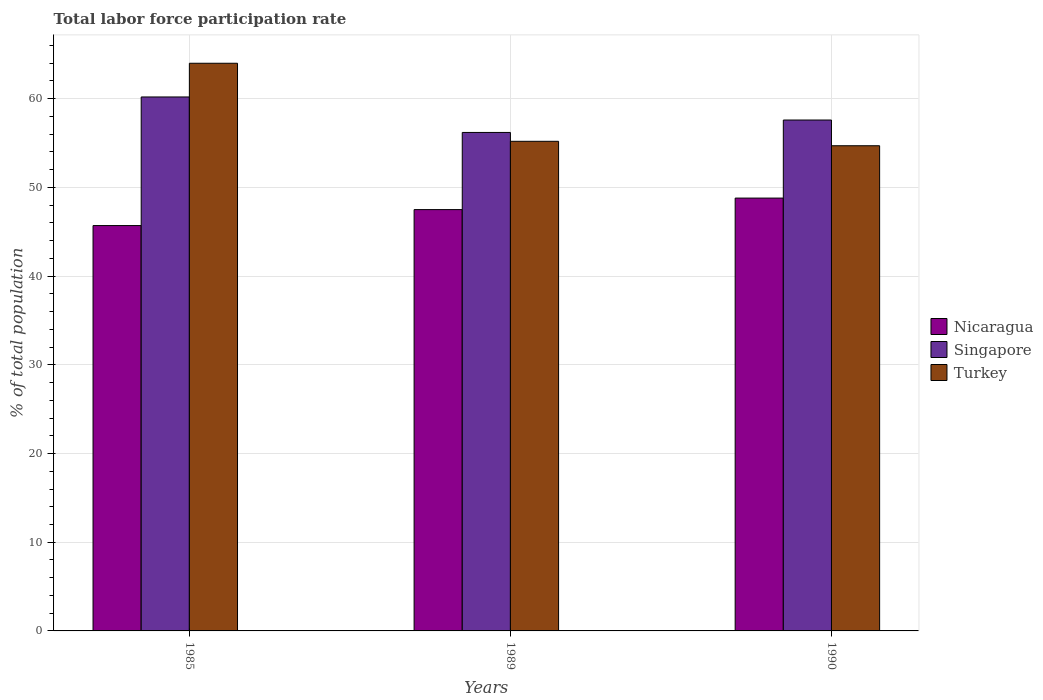How many groups of bars are there?
Your response must be concise. 3. How many bars are there on the 1st tick from the left?
Make the answer very short. 3. In how many cases, is the number of bars for a given year not equal to the number of legend labels?
Provide a succinct answer. 0. What is the total labor force participation rate in Nicaragua in 1990?
Make the answer very short. 48.8. Across all years, what is the maximum total labor force participation rate in Turkey?
Ensure brevity in your answer.  64. Across all years, what is the minimum total labor force participation rate in Turkey?
Provide a succinct answer. 54.7. What is the total total labor force participation rate in Singapore in the graph?
Ensure brevity in your answer.  174. What is the difference between the total labor force participation rate in Nicaragua in 1989 and that in 1990?
Provide a succinct answer. -1.3. What is the difference between the total labor force participation rate in Singapore in 1989 and the total labor force participation rate in Turkey in 1985?
Ensure brevity in your answer.  -7.8. What is the average total labor force participation rate in Turkey per year?
Keep it short and to the point. 57.97. In the year 1990, what is the difference between the total labor force participation rate in Nicaragua and total labor force participation rate in Turkey?
Keep it short and to the point. -5.9. In how many years, is the total labor force participation rate in Turkey greater than 46 %?
Make the answer very short. 3. What is the ratio of the total labor force participation rate in Singapore in 1985 to that in 1989?
Give a very brief answer. 1.07. Is the total labor force participation rate in Nicaragua in 1985 less than that in 1990?
Offer a very short reply. Yes. Is the difference between the total labor force participation rate in Nicaragua in 1985 and 1990 greater than the difference between the total labor force participation rate in Turkey in 1985 and 1990?
Make the answer very short. No. What is the difference between the highest and the second highest total labor force participation rate in Singapore?
Your answer should be very brief. 2.6. What is the difference between the highest and the lowest total labor force participation rate in Singapore?
Give a very brief answer. 4. Is the sum of the total labor force participation rate in Turkey in 1989 and 1990 greater than the maximum total labor force participation rate in Singapore across all years?
Provide a short and direct response. Yes. What does the 1st bar from the left in 1989 represents?
Keep it short and to the point. Nicaragua. What does the 2nd bar from the right in 1990 represents?
Give a very brief answer. Singapore. How many years are there in the graph?
Make the answer very short. 3. What is the difference between two consecutive major ticks on the Y-axis?
Give a very brief answer. 10. Are the values on the major ticks of Y-axis written in scientific E-notation?
Your answer should be compact. No. Does the graph contain any zero values?
Provide a short and direct response. No. Does the graph contain grids?
Your answer should be compact. Yes. How are the legend labels stacked?
Keep it short and to the point. Vertical. What is the title of the graph?
Provide a succinct answer. Total labor force participation rate. What is the label or title of the X-axis?
Provide a succinct answer. Years. What is the label or title of the Y-axis?
Offer a very short reply. % of total population. What is the % of total population in Nicaragua in 1985?
Offer a very short reply. 45.7. What is the % of total population of Singapore in 1985?
Keep it short and to the point. 60.2. What is the % of total population of Turkey in 1985?
Your answer should be compact. 64. What is the % of total population in Nicaragua in 1989?
Give a very brief answer. 47.5. What is the % of total population of Singapore in 1989?
Make the answer very short. 56.2. What is the % of total population of Turkey in 1989?
Keep it short and to the point. 55.2. What is the % of total population of Nicaragua in 1990?
Give a very brief answer. 48.8. What is the % of total population of Singapore in 1990?
Make the answer very short. 57.6. What is the % of total population of Turkey in 1990?
Make the answer very short. 54.7. Across all years, what is the maximum % of total population of Nicaragua?
Provide a short and direct response. 48.8. Across all years, what is the maximum % of total population in Singapore?
Ensure brevity in your answer.  60.2. Across all years, what is the maximum % of total population of Turkey?
Your answer should be very brief. 64. Across all years, what is the minimum % of total population in Nicaragua?
Give a very brief answer. 45.7. Across all years, what is the minimum % of total population in Singapore?
Your answer should be compact. 56.2. Across all years, what is the minimum % of total population in Turkey?
Offer a very short reply. 54.7. What is the total % of total population of Nicaragua in the graph?
Ensure brevity in your answer.  142. What is the total % of total population in Singapore in the graph?
Offer a terse response. 174. What is the total % of total population in Turkey in the graph?
Keep it short and to the point. 173.9. What is the difference between the % of total population of Nicaragua in 1985 and that in 1989?
Make the answer very short. -1.8. What is the difference between the % of total population in Singapore in 1985 and that in 1989?
Ensure brevity in your answer.  4. What is the difference between the % of total population in Turkey in 1985 and that in 1989?
Keep it short and to the point. 8.8. What is the difference between the % of total population in Nicaragua in 1985 and that in 1990?
Ensure brevity in your answer.  -3.1. What is the difference between the % of total population of Singapore in 1985 and that in 1990?
Offer a terse response. 2.6. What is the difference between the % of total population of Turkey in 1989 and that in 1990?
Offer a very short reply. 0.5. What is the difference between the % of total population in Nicaragua in 1985 and the % of total population in Singapore in 1989?
Provide a succinct answer. -10.5. What is the difference between the % of total population of Singapore in 1985 and the % of total population of Turkey in 1989?
Your answer should be very brief. 5. What is the difference between the % of total population of Nicaragua in 1985 and the % of total population of Singapore in 1990?
Keep it short and to the point. -11.9. What is the difference between the % of total population in Nicaragua in 1985 and the % of total population in Turkey in 1990?
Offer a terse response. -9. What is the difference between the % of total population of Nicaragua in 1989 and the % of total population of Turkey in 1990?
Give a very brief answer. -7.2. What is the average % of total population in Nicaragua per year?
Provide a short and direct response. 47.33. What is the average % of total population in Turkey per year?
Your response must be concise. 57.97. In the year 1985, what is the difference between the % of total population in Nicaragua and % of total population in Singapore?
Offer a very short reply. -14.5. In the year 1985, what is the difference between the % of total population of Nicaragua and % of total population of Turkey?
Your answer should be compact. -18.3. In the year 1985, what is the difference between the % of total population of Singapore and % of total population of Turkey?
Ensure brevity in your answer.  -3.8. In the year 1989, what is the difference between the % of total population in Nicaragua and % of total population in Turkey?
Offer a very short reply. -7.7. In the year 1990, what is the difference between the % of total population in Nicaragua and % of total population in Singapore?
Your answer should be compact. -8.8. What is the ratio of the % of total population in Nicaragua in 1985 to that in 1989?
Ensure brevity in your answer.  0.96. What is the ratio of the % of total population in Singapore in 1985 to that in 1989?
Your answer should be very brief. 1.07. What is the ratio of the % of total population of Turkey in 1985 to that in 1989?
Give a very brief answer. 1.16. What is the ratio of the % of total population of Nicaragua in 1985 to that in 1990?
Provide a short and direct response. 0.94. What is the ratio of the % of total population in Singapore in 1985 to that in 1990?
Offer a terse response. 1.05. What is the ratio of the % of total population in Turkey in 1985 to that in 1990?
Ensure brevity in your answer.  1.17. What is the ratio of the % of total population in Nicaragua in 1989 to that in 1990?
Give a very brief answer. 0.97. What is the ratio of the % of total population in Singapore in 1989 to that in 1990?
Ensure brevity in your answer.  0.98. What is the ratio of the % of total population in Turkey in 1989 to that in 1990?
Keep it short and to the point. 1.01. What is the difference between the highest and the second highest % of total population in Singapore?
Offer a terse response. 2.6. What is the difference between the highest and the second highest % of total population in Turkey?
Keep it short and to the point. 8.8. What is the difference between the highest and the lowest % of total population in Singapore?
Offer a very short reply. 4. What is the difference between the highest and the lowest % of total population of Turkey?
Offer a very short reply. 9.3. 